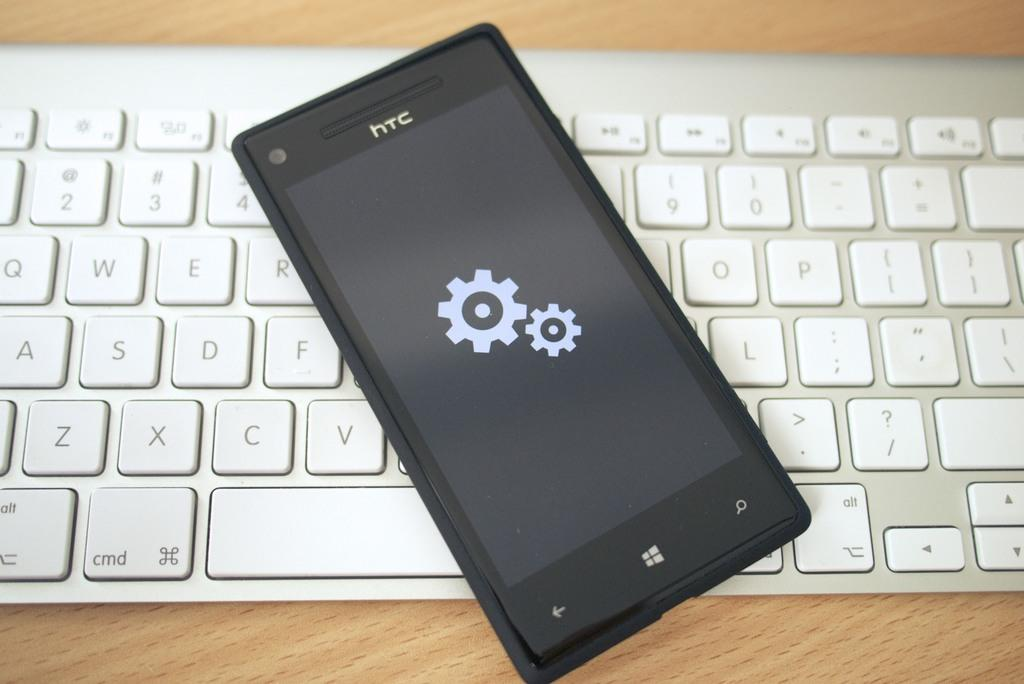<image>
Relay a brief, clear account of the picture shown. The front of an HTC phone has a large and a small cog on its screen as it rests on a white keyboard. 